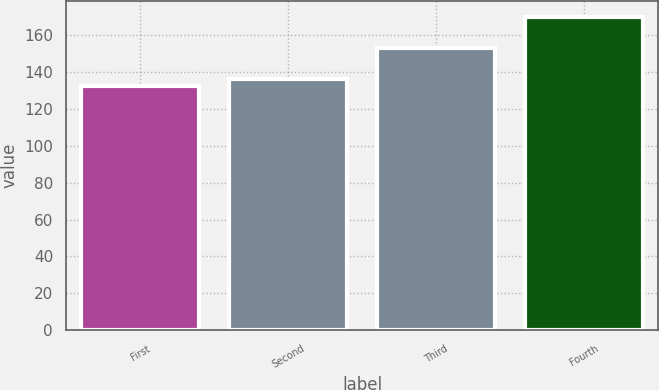Convert chart. <chart><loc_0><loc_0><loc_500><loc_500><bar_chart><fcel>First<fcel>Second<fcel>Third<fcel>Fourth<nl><fcel>132.19<fcel>135.94<fcel>152.86<fcel>169.64<nl></chart> 